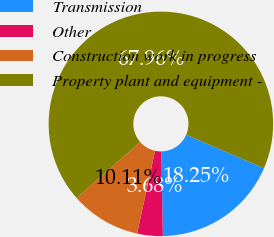Convert chart. <chart><loc_0><loc_0><loc_500><loc_500><pie_chart><fcel>Transmission<fcel>Other<fcel>Construction work in progress<fcel>Property plant and equipment -<nl><fcel>18.25%<fcel>3.68%<fcel>10.11%<fcel>67.96%<nl></chart> 